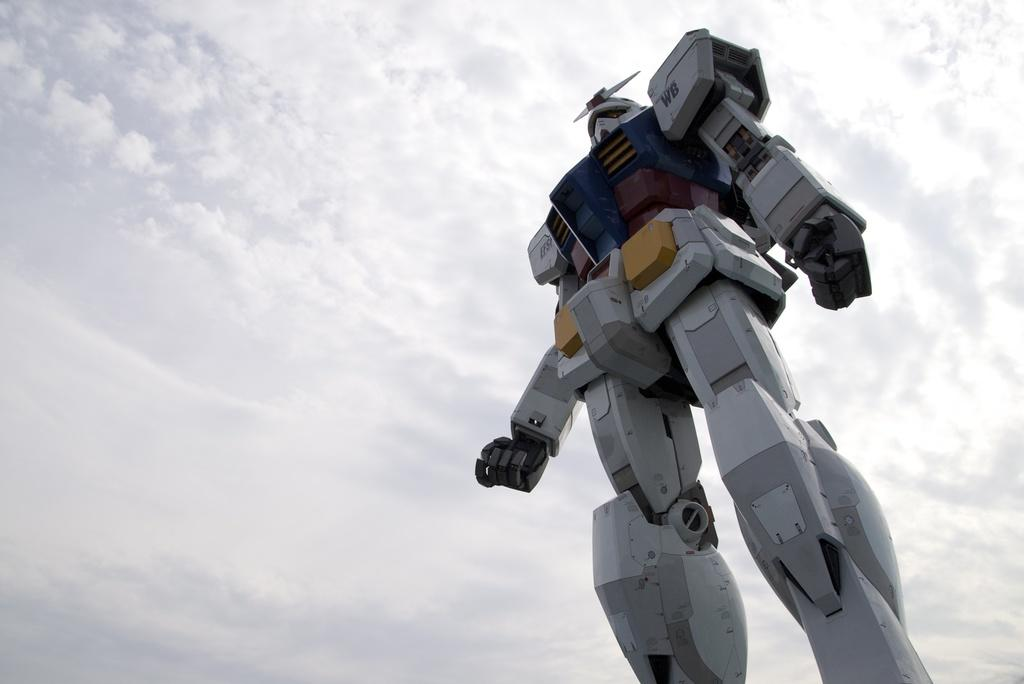What is the main subject in the foreground of the image? There is a robot in the foreground of the image. What can be seen in the background of the image? The background of the image includes the sky. What type of design is featured on the cactus in the image? There is no cactus present in the image, so it is not possible to answer that question. 